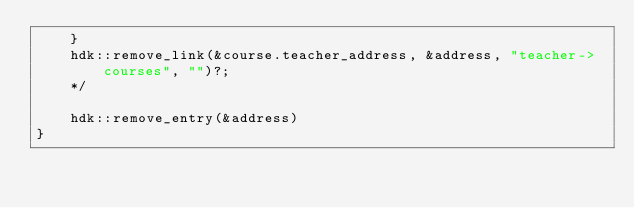<code> <loc_0><loc_0><loc_500><loc_500><_Rust_>    }
    hdk::remove_link(&course.teacher_address, &address, "teacher->courses", "")?;
    */

    hdk::remove_entry(&address)
}</code> 